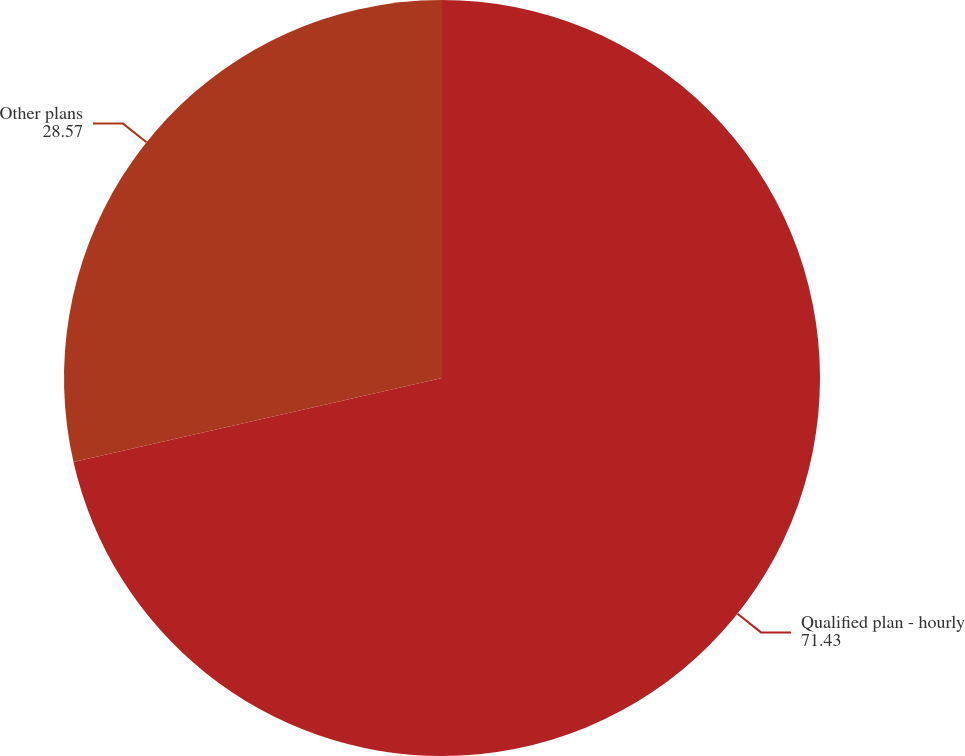<chart> <loc_0><loc_0><loc_500><loc_500><pie_chart><fcel>Qualified plan - hourly<fcel>Other plans<nl><fcel>71.43%<fcel>28.57%<nl></chart> 